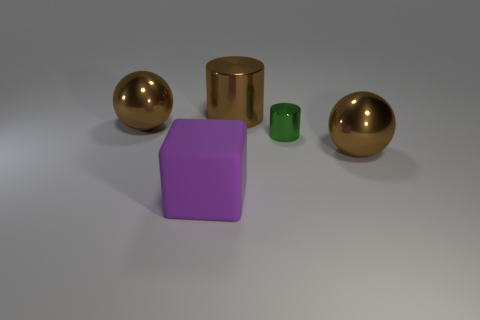What number of things are either large brown spheres that are on the left side of the green cylinder or metallic objects?
Give a very brief answer. 4. Are there more small shiny things than big metal things?
Provide a succinct answer. No. Is there a yellow cylinder that has the same size as the matte object?
Your response must be concise. No. How many things are spheres that are behind the green metal thing or small green cylinders that are behind the purple block?
Give a very brief answer. 2. What is the color of the object in front of the big brown sphere on the right side of the big matte cube?
Keep it short and to the point. Purple. There is another small cylinder that is the same material as the brown cylinder; what is its color?
Give a very brief answer. Green. How many balls have the same color as the big metallic cylinder?
Make the answer very short. 2. How many things are cylinders or green blocks?
Your response must be concise. 2. The purple object that is the same size as the brown metal cylinder is what shape?
Your response must be concise. Cube. What number of big objects are both behind the large matte object and on the left side of the small green object?
Provide a succinct answer. 2. 